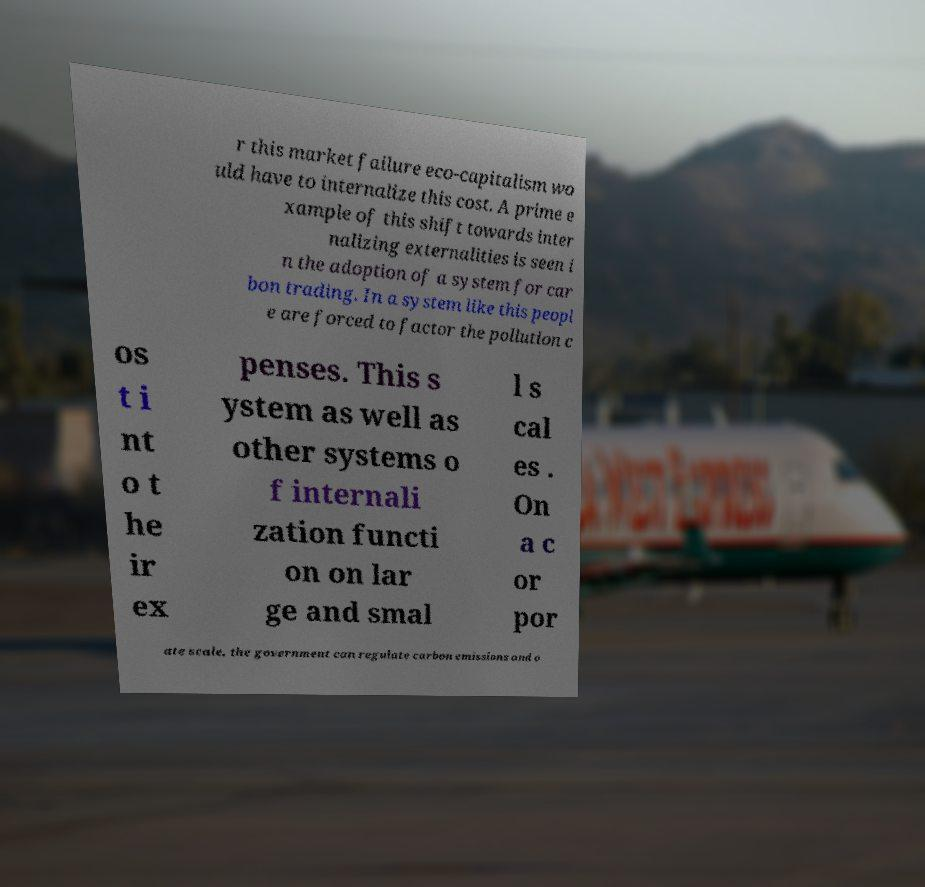Could you extract and type out the text from this image? r this market failure eco-capitalism wo uld have to internalize this cost. A prime e xample of this shift towards inter nalizing externalities is seen i n the adoption of a system for car bon trading. In a system like this peopl e are forced to factor the pollution c os t i nt o t he ir ex penses. This s ystem as well as other systems o f internali zation functi on on lar ge and smal l s cal es . On a c or por ate scale, the government can regulate carbon emissions and o 